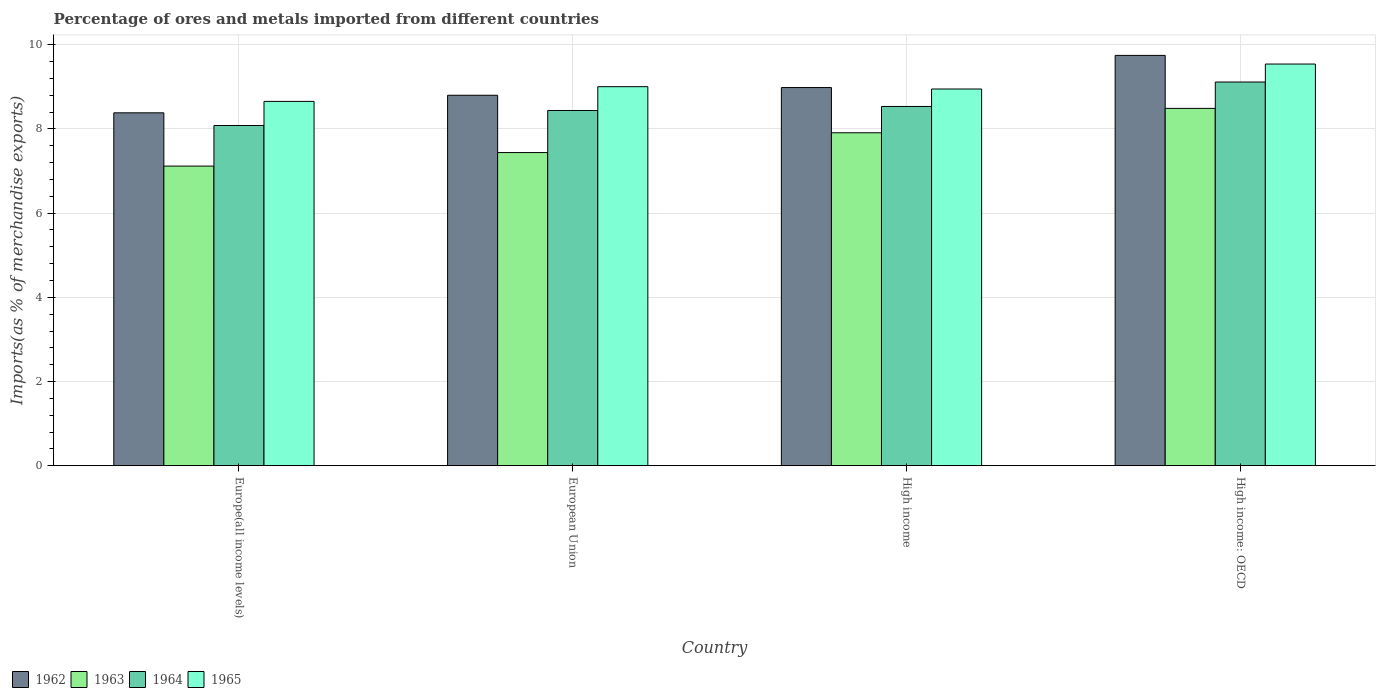How many different coloured bars are there?
Offer a terse response. 4. How many groups of bars are there?
Provide a succinct answer. 4. What is the label of the 4th group of bars from the left?
Your answer should be very brief. High income: OECD. In how many cases, is the number of bars for a given country not equal to the number of legend labels?
Your answer should be compact. 0. What is the percentage of imports to different countries in 1962 in European Union?
Make the answer very short. 8.8. Across all countries, what is the maximum percentage of imports to different countries in 1964?
Give a very brief answer. 9.11. Across all countries, what is the minimum percentage of imports to different countries in 1962?
Make the answer very short. 8.38. In which country was the percentage of imports to different countries in 1965 maximum?
Your answer should be compact. High income: OECD. In which country was the percentage of imports to different countries in 1965 minimum?
Your answer should be very brief. Europe(all income levels). What is the total percentage of imports to different countries in 1962 in the graph?
Offer a terse response. 35.91. What is the difference between the percentage of imports to different countries in 1962 in European Union and that in High income: OECD?
Provide a succinct answer. -0.95. What is the difference between the percentage of imports to different countries in 1962 in High income and the percentage of imports to different countries in 1964 in European Union?
Keep it short and to the point. 0.54. What is the average percentage of imports to different countries in 1962 per country?
Give a very brief answer. 8.98. What is the difference between the percentage of imports to different countries of/in 1965 and percentage of imports to different countries of/in 1964 in High income?
Your response must be concise. 0.41. In how many countries, is the percentage of imports to different countries in 1963 greater than 2 %?
Provide a short and direct response. 4. What is the ratio of the percentage of imports to different countries in 1965 in High income to that in High income: OECD?
Offer a terse response. 0.94. Is the percentage of imports to different countries in 1965 in Europe(all income levels) less than that in High income?
Your answer should be very brief. Yes. What is the difference between the highest and the second highest percentage of imports to different countries in 1962?
Your answer should be very brief. -0.76. What is the difference between the highest and the lowest percentage of imports to different countries in 1963?
Your answer should be very brief. 1.37. In how many countries, is the percentage of imports to different countries in 1963 greater than the average percentage of imports to different countries in 1963 taken over all countries?
Your answer should be very brief. 2. What does the 2nd bar from the left in Europe(all income levels) represents?
Ensure brevity in your answer.  1963. What does the 1st bar from the right in European Union represents?
Provide a succinct answer. 1965. Is it the case that in every country, the sum of the percentage of imports to different countries in 1964 and percentage of imports to different countries in 1963 is greater than the percentage of imports to different countries in 1965?
Give a very brief answer. Yes. How many bars are there?
Make the answer very short. 16. What is the difference between two consecutive major ticks on the Y-axis?
Provide a short and direct response. 2. Does the graph contain grids?
Ensure brevity in your answer.  Yes. Where does the legend appear in the graph?
Provide a succinct answer. Bottom left. How many legend labels are there?
Give a very brief answer. 4. How are the legend labels stacked?
Make the answer very short. Horizontal. What is the title of the graph?
Provide a succinct answer. Percentage of ores and metals imported from different countries. What is the label or title of the Y-axis?
Offer a terse response. Imports(as % of merchandise exports). What is the Imports(as % of merchandise exports) in 1962 in Europe(all income levels)?
Make the answer very short. 8.38. What is the Imports(as % of merchandise exports) of 1963 in Europe(all income levels)?
Provide a short and direct response. 7.12. What is the Imports(as % of merchandise exports) in 1964 in Europe(all income levels)?
Give a very brief answer. 8.08. What is the Imports(as % of merchandise exports) of 1965 in Europe(all income levels)?
Your response must be concise. 8.65. What is the Imports(as % of merchandise exports) in 1962 in European Union?
Offer a very short reply. 8.8. What is the Imports(as % of merchandise exports) in 1963 in European Union?
Your answer should be compact. 7.44. What is the Imports(as % of merchandise exports) of 1964 in European Union?
Your answer should be compact. 8.44. What is the Imports(as % of merchandise exports) of 1965 in European Union?
Provide a succinct answer. 9. What is the Imports(as % of merchandise exports) in 1962 in High income?
Your answer should be very brief. 8.98. What is the Imports(as % of merchandise exports) of 1963 in High income?
Give a very brief answer. 7.91. What is the Imports(as % of merchandise exports) in 1964 in High income?
Your answer should be very brief. 8.53. What is the Imports(as % of merchandise exports) of 1965 in High income?
Your answer should be very brief. 8.95. What is the Imports(as % of merchandise exports) in 1962 in High income: OECD?
Ensure brevity in your answer.  9.75. What is the Imports(as % of merchandise exports) of 1963 in High income: OECD?
Provide a short and direct response. 8.49. What is the Imports(as % of merchandise exports) in 1964 in High income: OECD?
Give a very brief answer. 9.11. What is the Imports(as % of merchandise exports) of 1965 in High income: OECD?
Ensure brevity in your answer.  9.54. Across all countries, what is the maximum Imports(as % of merchandise exports) of 1962?
Give a very brief answer. 9.75. Across all countries, what is the maximum Imports(as % of merchandise exports) of 1963?
Provide a succinct answer. 8.49. Across all countries, what is the maximum Imports(as % of merchandise exports) in 1964?
Give a very brief answer. 9.11. Across all countries, what is the maximum Imports(as % of merchandise exports) in 1965?
Provide a succinct answer. 9.54. Across all countries, what is the minimum Imports(as % of merchandise exports) of 1962?
Offer a very short reply. 8.38. Across all countries, what is the minimum Imports(as % of merchandise exports) in 1963?
Offer a terse response. 7.12. Across all countries, what is the minimum Imports(as % of merchandise exports) in 1964?
Your answer should be compact. 8.08. Across all countries, what is the minimum Imports(as % of merchandise exports) in 1965?
Your response must be concise. 8.65. What is the total Imports(as % of merchandise exports) in 1962 in the graph?
Keep it short and to the point. 35.91. What is the total Imports(as % of merchandise exports) in 1963 in the graph?
Offer a very short reply. 30.95. What is the total Imports(as % of merchandise exports) of 1964 in the graph?
Keep it short and to the point. 34.17. What is the total Imports(as % of merchandise exports) in 1965 in the graph?
Keep it short and to the point. 36.15. What is the difference between the Imports(as % of merchandise exports) of 1962 in Europe(all income levels) and that in European Union?
Ensure brevity in your answer.  -0.42. What is the difference between the Imports(as % of merchandise exports) of 1963 in Europe(all income levels) and that in European Union?
Give a very brief answer. -0.32. What is the difference between the Imports(as % of merchandise exports) in 1964 in Europe(all income levels) and that in European Union?
Provide a short and direct response. -0.36. What is the difference between the Imports(as % of merchandise exports) in 1965 in Europe(all income levels) and that in European Union?
Ensure brevity in your answer.  -0.35. What is the difference between the Imports(as % of merchandise exports) of 1962 in Europe(all income levels) and that in High income?
Provide a succinct answer. -0.6. What is the difference between the Imports(as % of merchandise exports) of 1963 in Europe(all income levels) and that in High income?
Your answer should be compact. -0.79. What is the difference between the Imports(as % of merchandise exports) in 1964 in Europe(all income levels) and that in High income?
Your answer should be compact. -0.45. What is the difference between the Imports(as % of merchandise exports) in 1965 in Europe(all income levels) and that in High income?
Your answer should be compact. -0.29. What is the difference between the Imports(as % of merchandise exports) in 1962 in Europe(all income levels) and that in High income: OECD?
Provide a short and direct response. -1.36. What is the difference between the Imports(as % of merchandise exports) in 1963 in Europe(all income levels) and that in High income: OECD?
Keep it short and to the point. -1.37. What is the difference between the Imports(as % of merchandise exports) in 1964 in Europe(all income levels) and that in High income: OECD?
Keep it short and to the point. -1.03. What is the difference between the Imports(as % of merchandise exports) in 1965 in Europe(all income levels) and that in High income: OECD?
Your response must be concise. -0.89. What is the difference between the Imports(as % of merchandise exports) of 1962 in European Union and that in High income?
Provide a short and direct response. -0.18. What is the difference between the Imports(as % of merchandise exports) in 1963 in European Union and that in High income?
Ensure brevity in your answer.  -0.47. What is the difference between the Imports(as % of merchandise exports) of 1964 in European Union and that in High income?
Your answer should be very brief. -0.1. What is the difference between the Imports(as % of merchandise exports) in 1965 in European Union and that in High income?
Keep it short and to the point. 0.06. What is the difference between the Imports(as % of merchandise exports) of 1962 in European Union and that in High income: OECD?
Ensure brevity in your answer.  -0.95. What is the difference between the Imports(as % of merchandise exports) in 1963 in European Union and that in High income: OECD?
Your answer should be compact. -1.05. What is the difference between the Imports(as % of merchandise exports) in 1964 in European Union and that in High income: OECD?
Provide a succinct answer. -0.68. What is the difference between the Imports(as % of merchandise exports) in 1965 in European Union and that in High income: OECD?
Offer a very short reply. -0.54. What is the difference between the Imports(as % of merchandise exports) of 1962 in High income and that in High income: OECD?
Keep it short and to the point. -0.76. What is the difference between the Imports(as % of merchandise exports) in 1963 in High income and that in High income: OECD?
Your answer should be very brief. -0.58. What is the difference between the Imports(as % of merchandise exports) of 1964 in High income and that in High income: OECD?
Ensure brevity in your answer.  -0.58. What is the difference between the Imports(as % of merchandise exports) in 1965 in High income and that in High income: OECD?
Give a very brief answer. -0.59. What is the difference between the Imports(as % of merchandise exports) in 1962 in Europe(all income levels) and the Imports(as % of merchandise exports) in 1963 in European Union?
Give a very brief answer. 0.94. What is the difference between the Imports(as % of merchandise exports) of 1962 in Europe(all income levels) and the Imports(as % of merchandise exports) of 1964 in European Union?
Offer a very short reply. -0.06. What is the difference between the Imports(as % of merchandise exports) in 1962 in Europe(all income levels) and the Imports(as % of merchandise exports) in 1965 in European Union?
Your answer should be compact. -0.62. What is the difference between the Imports(as % of merchandise exports) of 1963 in Europe(all income levels) and the Imports(as % of merchandise exports) of 1964 in European Union?
Provide a succinct answer. -1.32. What is the difference between the Imports(as % of merchandise exports) in 1963 in Europe(all income levels) and the Imports(as % of merchandise exports) in 1965 in European Union?
Ensure brevity in your answer.  -1.89. What is the difference between the Imports(as % of merchandise exports) in 1964 in Europe(all income levels) and the Imports(as % of merchandise exports) in 1965 in European Union?
Offer a very short reply. -0.92. What is the difference between the Imports(as % of merchandise exports) of 1962 in Europe(all income levels) and the Imports(as % of merchandise exports) of 1963 in High income?
Provide a succinct answer. 0.47. What is the difference between the Imports(as % of merchandise exports) of 1962 in Europe(all income levels) and the Imports(as % of merchandise exports) of 1964 in High income?
Your answer should be compact. -0.15. What is the difference between the Imports(as % of merchandise exports) of 1962 in Europe(all income levels) and the Imports(as % of merchandise exports) of 1965 in High income?
Ensure brevity in your answer.  -0.57. What is the difference between the Imports(as % of merchandise exports) of 1963 in Europe(all income levels) and the Imports(as % of merchandise exports) of 1964 in High income?
Offer a terse response. -1.42. What is the difference between the Imports(as % of merchandise exports) of 1963 in Europe(all income levels) and the Imports(as % of merchandise exports) of 1965 in High income?
Your response must be concise. -1.83. What is the difference between the Imports(as % of merchandise exports) of 1964 in Europe(all income levels) and the Imports(as % of merchandise exports) of 1965 in High income?
Ensure brevity in your answer.  -0.87. What is the difference between the Imports(as % of merchandise exports) of 1962 in Europe(all income levels) and the Imports(as % of merchandise exports) of 1963 in High income: OECD?
Your response must be concise. -0.11. What is the difference between the Imports(as % of merchandise exports) of 1962 in Europe(all income levels) and the Imports(as % of merchandise exports) of 1964 in High income: OECD?
Keep it short and to the point. -0.73. What is the difference between the Imports(as % of merchandise exports) of 1962 in Europe(all income levels) and the Imports(as % of merchandise exports) of 1965 in High income: OECD?
Your response must be concise. -1.16. What is the difference between the Imports(as % of merchandise exports) in 1963 in Europe(all income levels) and the Imports(as % of merchandise exports) in 1964 in High income: OECD?
Make the answer very short. -2. What is the difference between the Imports(as % of merchandise exports) in 1963 in Europe(all income levels) and the Imports(as % of merchandise exports) in 1965 in High income: OECD?
Keep it short and to the point. -2.42. What is the difference between the Imports(as % of merchandise exports) in 1964 in Europe(all income levels) and the Imports(as % of merchandise exports) in 1965 in High income: OECD?
Offer a terse response. -1.46. What is the difference between the Imports(as % of merchandise exports) in 1962 in European Union and the Imports(as % of merchandise exports) in 1963 in High income?
Keep it short and to the point. 0.89. What is the difference between the Imports(as % of merchandise exports) of 1962 in European Union and the Imports(as % of merchandise exports) of 1964 in High income?
Your response must be concise. 0.27. What is the difference between the Imports(as % of merchandise exports) in 1962 in European Union and the Imports(as % of merchandise exports) in 1965 in High income?
Make the answer very short. -0.15. What is the difference between the Imports(as % of merchandise exports) of 1963 in European Union and the Imports(as % of merchandise exports) of 1964 in High income?
Make the answer very short. -1.1. What is the difference between the Imports(as % of merchandise exports) of 1963 in European Union and the Imports(as % of merchandise exports) of 1965 in High income?
Your answer should be very brief. -1.51. What is the difference between the Imports(as % of merchandise exports) of 1964 in European Union and the Imports(as % of merchandise exports) of 1965 in High income?
Offer a terse response. -0.51. What is the difference between the Imports(as % of merchandise exports) of 1962 in European Union and the Imports(as % of merchandise exports) of 1963 in High income: OECD?
Offer a very short reply. 0.31. What is the difference between the Imports(as % of merchandise exports) of 1962 in European Union and the Imports(as % of merchandise exports) of 1964 in High income: OECD?
Give a very brief answer. -0.31. What is the difference between the Imports(as % of merchandise exports) in 1962 in European Union and the Imports(as % of merchandise exports) in 1965 in High income: OECD?
Provide a short and direct response. -0.74. What is the difference between the Imports(as % of merchandise exports) of 1963 in European Union and the Imports(as % of merchandise exports) of 1964 in High income: OECD?
Your answer should be very brief. -1.68. What is the difference between the Imports(as % of merchandise exports) of 1963 in European Union and the Imports(as % of merchandise exports) of 1965 in High income: OECD?
Provide a short and direct response. -2.1. What is the difference between the Imports(as % of merchandise exports) of 1964 in European Union and the Imports(as % of merchandise exports) of 1965 in High income: OECD?
Your response must be concise. -1.1. What is the difference between the Imports(as % of merchandise exports) in 1962 in High income and the Imports(as % of merchandise exports) in 1963 in High income: OECD?
Keep it short and to the point. 0.49. What is the difference between the Imports(as % of merchandise exports) in 1962 in High income and the Imports(as % of merchandise exports) in 1964 in High income: OECD?
Ensure brevity in your answer.  -0.13. What is the difference between the Imports(as % of merchandise exports) of 1962 in High income and the Imports(as % of merchandise exports) of 1965 in High income: OECD?
Your answer should be very brief. -0.56. What is the difference between the Imports(as % of merchandise exports) in 1963 in High income and the Imports(as % of merchandise exports) in 1964 in High income: OECD?
Provide a succinct answer. -1.21. What is the difference between the Imports(as % of merchandise exports) in 1963 in High income and the Imports(as % of merchandise exports) in 1965 in High income: OECD?
Give a very brief answer. -1.63. What is the difference between the Imports(as % of merchandise exports) of 1964 in High income and the Imports(as % of merchandise exports) of 1965 in High income: OECD?
Provide a short and direct response. -1.01. What is the average Imports(as % of merchandise exports) of 1962 per country?
Provide a short and direct response. 8.98. What is the average Imports(as % of merchandise exports) of 1963 per country?
Keep it short and to the point. 7.74. What is the average Imports(as % of merchandise exports) of 1964 per country?
Keep it short and to the point. 8.54. What is the average Imports(as % of merchandise exports) in 1965 per country?
Make the answer very short. 9.04. What is the difference between the Imports(as % of merchandise exports) in 1962 and Imports(as % of merchandise exports) in 1963 in Europe(all income levels)?
Offer a very short reply. 1.26. What is the difference between the Imports(as % of merchandise exports) in 1962 and Imports(as % of merchandise exports) in 1964 in Europe(all income levels)?
Your answer should be very brief. 0.3. What is the difference between the Imports(as % of merchandise exports) in 1962 and Imports(as % of merchandise exports) in 1965 in Europe(all income levels)?
Ensure brevity in your answer.  -0.27. What is the difference between the Imports(as % of merchandise exports) of 1963 and Imports(as % of merchandise exports) of 1964 in Europe(all income levels)?
Your response must be concise. -0.96. What is the difference between the Imports(as % of merchandise exports) in 1963 and Imports(as % of merchandise exports) in 1965 in Europe(all income levels)?
Offer a terse response. -1.54. What is the difference between the Imports(as % of merchandise exports) in 1964 and Imports(as % of merchandise exports) in 1965 in Europe(all income levels)?
Provide a short and direct response. -0.57. What is the difference between the Imports(as % of merchandise exports) of 1962 and Imports(as % of merchandise exports) of 1963 in European Union?
Provide a short and direct response. 1.36. What is the difference between the Imports(as % of merchandise exports) in 1962 and Imports(as % of merchandise exports) in 1964 in European Union?
Your response must be concise. 0.36. What is the difference between the Imports(as % of merchandise exports) of 1962 and Imports(as % of merchandise exports) of 1965 in European Union?
Provide a short and direct response. -0.2. What is the difference between the Imports(as % of merchandise exports) of 1963 and Imports(as % of merchandise exports) of 1964 in European Union?
Give a very brief answer. -1. What is the difference between the Imports(as % of merchandise exports) of 1963 and Imports(as % of merchandise exports) of 1965 in European Union?
Give a very brief answer. -1.57. What is the difference between the Imports(as % of merchandise exports) in 1964 and Imports(as % of merchandise exports) in 1965 in European Union?
Ensure brevity in your answer.  -0.56. What is the difference between the Imports(as % of merchandise exports) of 1962 and Imports(as % of merchandise exports) of 1963 in High income?
Offer a terse response. 1.07. What is the difference between the Imports(as % of merchandise exports) in 1962 and Imports(as % of merchandise exports) in 1964 in High income?
Your answer should be very brief. 0.45. What is the difference between the Imports(as % of merchandise exports) of 1962 and Imports(as % of merchandise exports) of 1965 in High income?
Your answer should be very brief. 0.03. What is the difference between the Imports(as % of merchandise exports) of 1963 and Imports(as % of merchandise exports) of 1964 in High income?
Your answer should be very brief. -0.63. What is the difference between the Imports(as % of merchandise exports) in 1963 and Imports(as % of merchandise exports) in 1965 in High income?
Provide a succinct answer. -1.04. What is the difference between the Imports(as % of merchandise exports) of 1964 and Imports(as % of merchandise exports) of 1965 in High income?
Provide a succinct answer. -0.41. What is the difference between the Imports(as % of merchandise exports) in 1962 and Imports(as % of merchandise exports) in 1963 in High income: OECD?
Make the answer very short. 1.26. What is the difference between the Imports(as % of merchandise exports) in 1962 and Imports(as % of merchandise exports) in 1964 in High income: OECD?
Offer a very short reply. 0.63. What is the difference between the Imports(as % of merchandise exports) in 1962 and Imports(as % of merchandise exports) in 1965 in High income: OECD?
Your answer should be very brief. 0.21. What is the difference between the Imports(as % of merchandise exports) in 1963 and Imports(as % of merchandise exports) in 1964 in High income: OECD?
Make the answer very short. -0.63. What is the difference between the Imports(as % of merchandise exports) of 1963 and Imports(as % of merchandise exports) of 1965 in High income: OECD?
Your answer should be compact. -1.05. What is the difference between the Imports(as % of merchandise exports) of 1964 and Imports(as % of merchandise exports) of 1965 in High income: OECD?
Keep it short and to the point. -0.43. What is the ratio of the Imports(as % of merchandise exports) of 1962 in Europe(all income levels) to that in European Union?
Offer a very short reply. 0.95. What is the ratio of the Imports(as % of merchandise exports) in 1963 in Europe(all income levels) to that in European Union?
Your answer should be compact. 0.96. What is the ratio of the Imports(as % of merchandise exports) in 1964 in Europe(all income levels) to that in European Union?
Keep it short and to the point. 0.96. What is the ratio of the Imports(as % of merchandise exports) in 1965 in Europe(all income levels) to that in European Union?
Your answer should be compact. 0.96. What is the ratio of the Imports(as % of merchandise exports) in 1962 in Europe(all income levels) to that in High income?
Offer a terse response. 0.93. What is the ratio of the Imports(as % of merchandise exports) of 1963 in Europe(all income levels) to that in High income?
Your response must be concise. 0.9. What is the ratio of the Imports(as % of merchandise exports) of 1964 in Europe(all income levels) to that in High income?
Provide a short and direct response. 0.95. What is the ratio of the Imports(as % of merchandise exports) of 1965 in Europe(all income levels) to that in High income?
Provide a succinct answer. 0.97. What is the ratio of the Imports(as % of merchandise exports) in 1962 in Europe(all income levels) to that in High income: OECD?
Offer a very short reply. 0.86. What is the ratio of the Imports(as % of merchandise exports) of 1963 in Europe(all income levels) to that in High income: OECD?
Ensure brevity in your answer.  0.84. What is the ratio of the Imports(as % of merchandise exports) of 1964 in Europe(all income levels) to that in High income: OECD?
Offer a terse response. 0.89. What is the ratio of the Imports(as % of merchandise exports) in 1965 in Europe(all income levels) to that in High income: OECD?
Ensure brevity in your answer.  0.91. What is the ratio of the Imports(as % of merchandise exports) in 1962 in European Union to that in High income?
Your answer should be very brief. 0.98. What is the ratio of the Imports(as % of merchandise exports) of 1963 in European Union to that in High income?
Your answer should be compact. 0.94. What is the ratio of the Imports(as % of merchandise exports) of 1962 in European Union to that in High income: OECD?
Your answer should be compact. 0.9. What is the ratio of the Imports(as % of merchandise exports) of 1963 in European Union to that in High income: OECD?
Your answer should be very brief. 0.88. What is the ratio of the Imports(as % of merchandise exports) in 1964 in European Union to that in High income: OECD?
Keep it short and to the point. 0.93. What is the ratio of the Imports(as % of merchandise exports) in 1965 in European Union to that in High income: OECD?
Your response must be concise. 0.94. What is the ratio of the Imports(as % of merchandise exports) of 1962 in High income to that in High income: OECD?
Provide a succinct answer. 0.92. What is the ratio of the Imports(as % of merchandise exports) in 1963 in High income to that in High income: OECD?
Offer a very short reply. 0.93. What is the ratio of the Imports(as % of merchandise exports) in 1964 in High income to that in High income: OECD?
Offer a terse response. 0.94. What is the ratio of the Imports(as % of merchandise exports) of 1965 in High income to that in High income: OECD?
Keep it short and to the point. 0.94. What is the difference between the highest and the second highest Imports(as % of merchandise exports) of 1962?
Give a very brief answer. 0.76. What is the difference between the highest and the second highest Imports(as % of merchandise exports) in 1963?
Your answer should be very brief. 0.58. What is the difference between the highest and the second highest Imports(as % of merchandise exports) of 1964?
Provide a succinct answer. 0.58. What is the difference between the highest and the second highest Imports(as % of merchandise exports) in 1965?
Provide a succinct answer. 0.54. What is the difference between the highest and the lowest Imports(as % of merchandise exports) in 1962?
Keep it short and to the point. 1.36. What is the difference between the highest and the lowest Imports(as % of merchandise exports) in 1963?
Provide a succinct answer. 1.37. What is the difference between the highest and the lowest Imports(as % of merchandise exports) in 1964?
Offer a terse response. 1.03. What is the difference between the highest and the lowest Imports(as % of merchandise exports) of 1965?
Offer a very short reply. 0.89. 